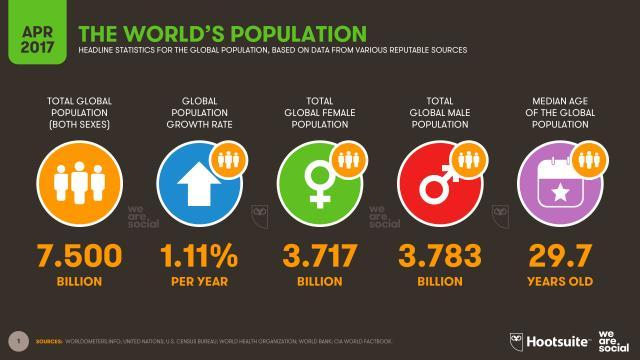What is the global population growth rate?
Answer the question with a short phrase. 1.11% What is the median age of the global population? 29.7 years old What is the total global female population? 3.717 What is the total global male population? 3.783 Billion What is the total population? 7.500 